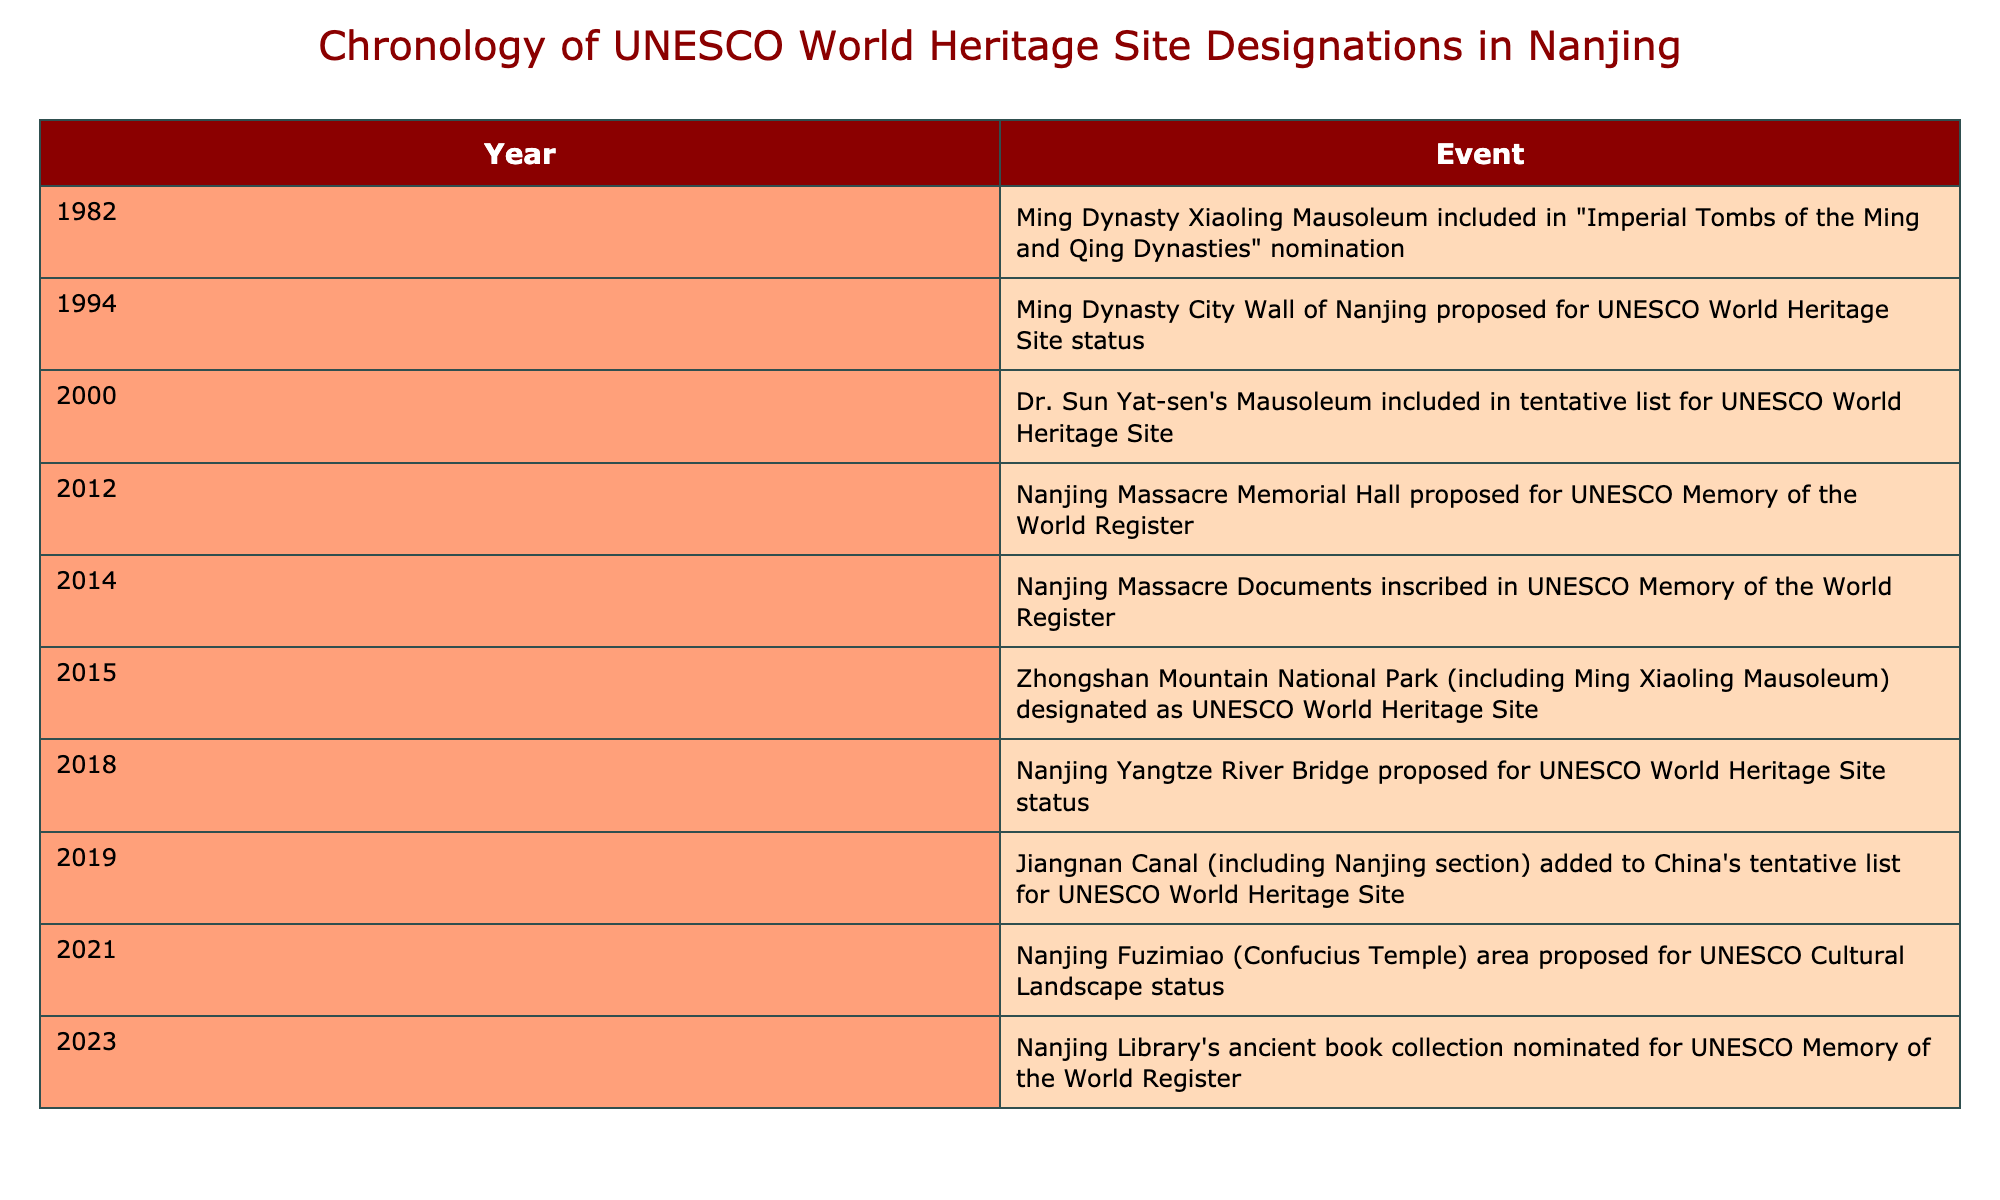What year was the Ming Dynasty Xiaoling Mausoleum included in the UNESCO nomination? According to the table, the Ming Dynasty Xiaoling Mausoleum was included in the UNESCO nomination in 1982.
Answer: 1982 How many events related to UNESCO World Heritage Site designations occurred in the year 2014? The table shows that there is one event in the year 2014, which is the inscription of the Nanjing Massacre Documents in the UNESCO Memory of the World Register.
Answer: 1 In which year was the Nanjing Massacre Memorial Hall proposed for UNESCO recognition? The table indicates that the Nanjing Massacre Memorial Hall was proposed in 2012.
Answer: 2012 Is it true that the Nanjing Yangtze River Bridge was proposed for UNESCO status before the Jiangnan Canal was added to the tentative list? The table shows that the Nanjing Yangtze River Bridge was proposed in 2018 and the Jiangnan Canal was added in 2019, so this statement is true.
Answer: Yes What is the time gap between the proposal for the Ming Dynasty City Wall and its eventual designation? The Ming Dynasty City Wall was proposed in 1994 and the Zhongshan Mountain National Park (which includes Ming Xiaoling Mausoleum) was designated as a UNESCO World Heritage Site in 2015. Therefore, the gap is 2015 - 1994 = 21 years.
Answer: 21 years How many events proposed UNESCO recognition from 2012 to 2021? From the table, the events proposed for UNESCO recognition between 2012 and 2021 are: the Nanjing Massacre Memorial Hall in 2012, the Jiangnan Canal in 2019, and the Nanjing Fuzimiao area in 2021. That totals three events.
Answer: 3 What is the difference in years between the designation of the Zhongshan Mountain National Park and the proposal for the Nanjing Library's ancient book collection? The designation of the Zhongshan Mountain National Park occurred in 2015 and the proposal for the Nanjing Library's ancient book collection was in 2023. The difference in years is 2023 - 2015 = 8 years.
Answer: 8 years How many events are listed from the year 2000 onwards? The table shows the following events from 2000 onwards: Dr. Sun Yat-sen's Mausoleum in 2000, the Nanjing Massacre Memorial Hall in 2012, the Nanjing Massacre Documents in 2014, designation of the Zhongshan Mountain National Park in 2015, the Nanjing Yangtze River Bridge in 2018, Jiangnan Canal in 2019, the Nanjing Fuzimiao area in 2021, and the Nanjing Library's collection in 2023. This makes a total of eight events.
Answer: 8 